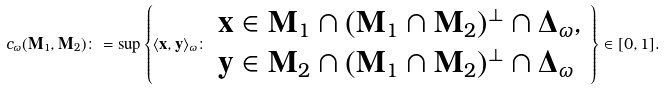<formula> <loc_0><loc_0><loc_500><loc_500>c _ { \omega } ( \mathbf M _ { 1 } , \mathbf M _ { 2 } ) \colon = \sup \left \{ \langle \mathbf x , \mathbf y \rangle _ { \omega } \colon \begin{array} { l } \mathbf x \in \mathbf M _ { 1 } \cap ( \mathbf M _ { 1 } \cap \mathbf M _ { 2 } ) ^ { \perp } \cap \mathbf \Delta _ { \omega } , \\ \mathbf y \in \mathbf M _ { 2 } \cap ( \mathbf M _ { 1 } \cap \mathbf M _ { 2 } ) ^ { \perp } \cap \mathbf \Delta _ { \omega } \end{array} \right \} \in [ 0 , 1 ] .</formula> 